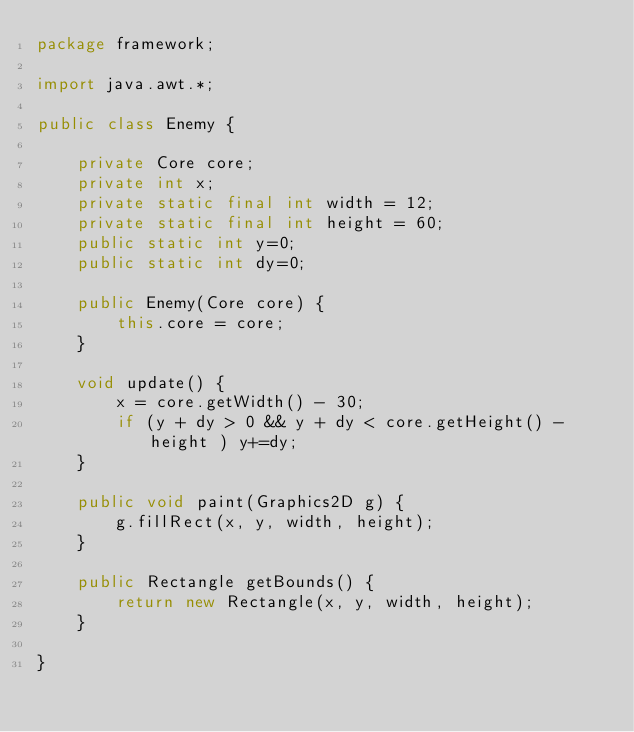Convert code to text. <code><loc_0><loc_0><loc_500><loc_500><_Java_>package framework;

import java.awt.*;

public class Enemy {

    private Core core;
    private int x;
    private static final int width = 12;
    private static final int height = 60;
    public static int y=0;
    public static int dy=0;

    public Enemy(Core core) {
        this.core = core;
    }

    void update() {
        x = core.getWidth() - 30;
        if (y + dy > 0 && y + dy < core.getHeight() - height ) y+=dy;
    }

    public void paint(Graphics2D g) {
        g.fillRect(x, y, width, height);
    }

    public Rectangle getBounds() {
        return new Rectangle(x, y, width, height);
    }

}</code> 